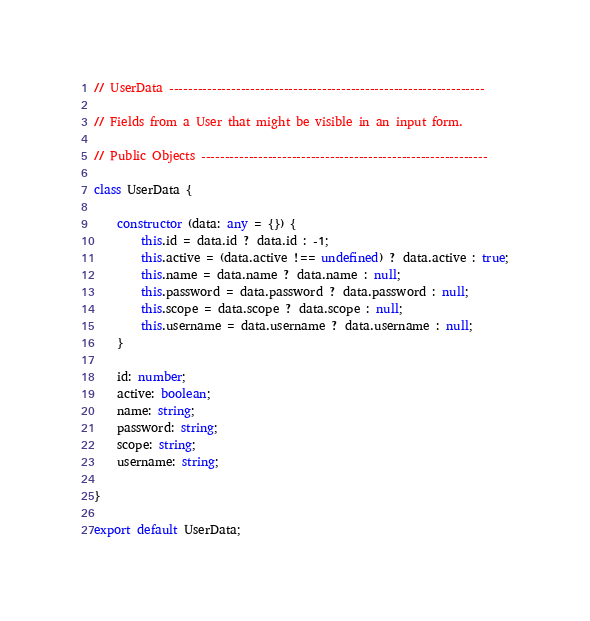Convert code to text. <code><loc_0><loc_0><loc_500><loc_500><_TypeScript_>// UserData ------------------------------------------------------------------

// Fields from a User that might be visible in an input form.

// Public Objects ------------------------------------------------------------

class UserData {

    constructor (data: any = {}) {
        this.id = data.id ? data.id : -1;
        this.active = (data.active !== undefined) ? data.active : true;
        this.name = data.name ? data.name : null;
        this.password = data.password ? data.password : null;
        this.scope = data.scope ? data.scope : null;
        this.username = data.username ? data.username : null;
    }

    id: number;
    active: boolean;
    name: string;
    password: string;
    scope: string;
    username: string;

}

export default UserData;
</code> 